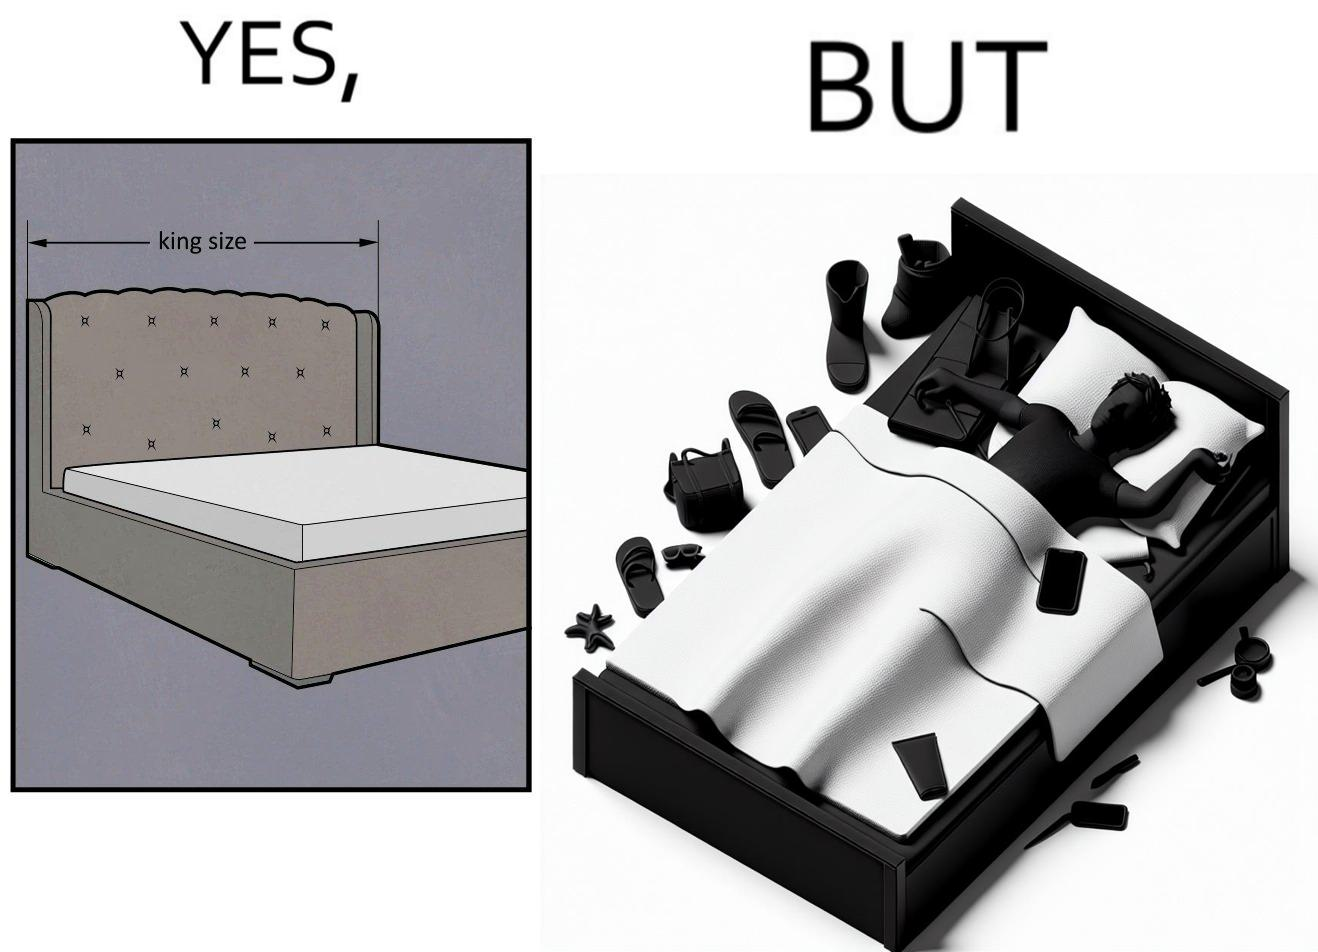What makes this image funny or satirical? Although the person has purchased a king size bed, but only less than half of the space is used by the person for sleeping. 